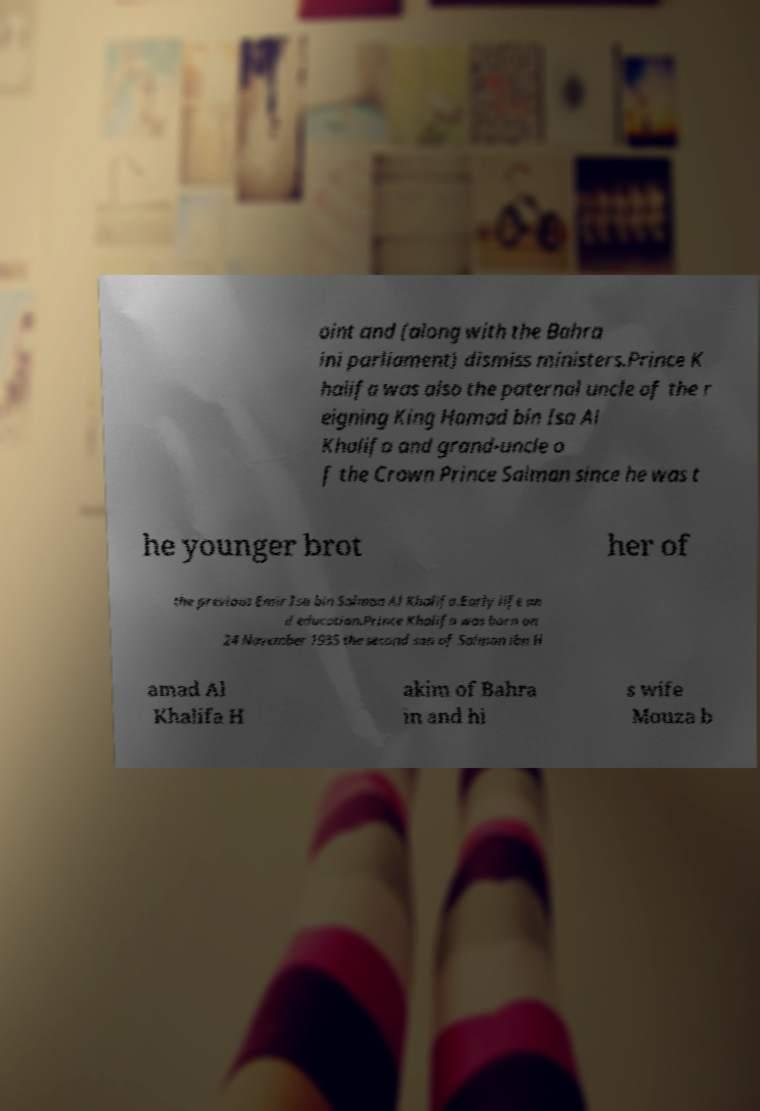Could you extract and type out the text from this image? oint and (along with the Bahra ini parliament) dismiss ministers.Prince K halifa was also the paternal uncle of the r eigning King Hamad bin Isa Al Khalifa and grand-uncle o f the Crown Prince Salman since he was t he younger brot her of the previous Emir Isa bin Salman Al Khalifa.Early life an d education.Prince Khalifa was born on 24 November 1935 the second son of Salman ibn H amad Al Khalifa H akim of Bahra in and hi s wife Mouza b 